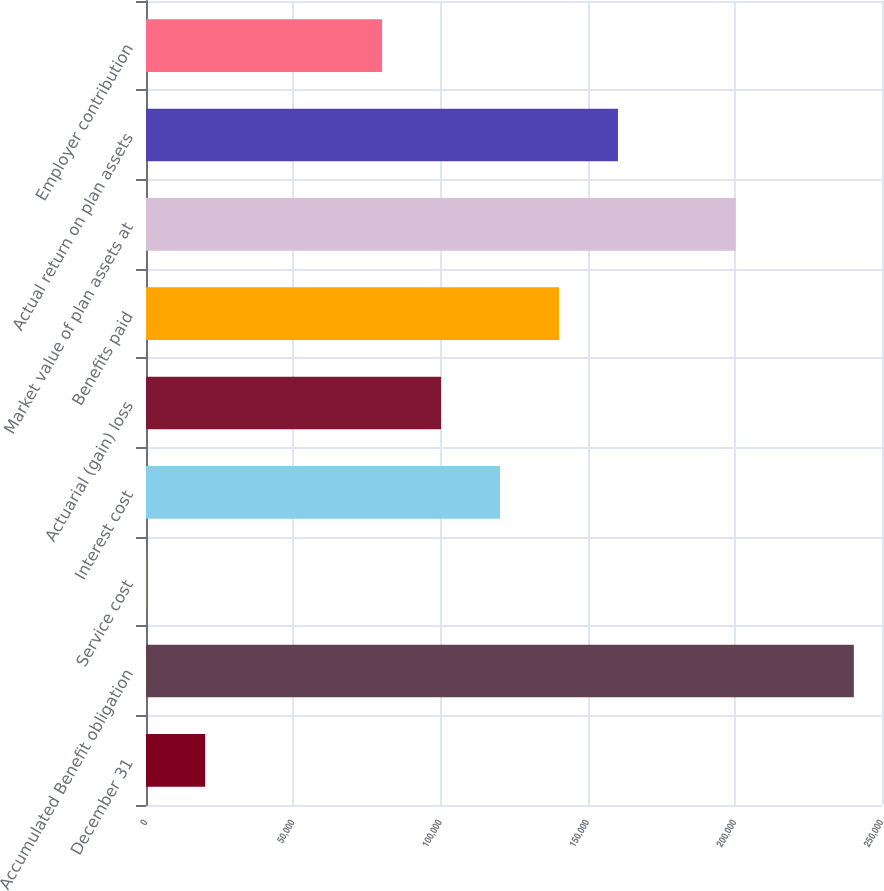Convert chart. <chart><loc_0><loc_0><loc_500><loc_500><bar_chart><fcel>December 31<fcel>Accumulated Benefit obligation<fcel>Service cost<fcel>Interest cost<fcel>Actuarial (gain) loss<fcel>Benefits paid<fcel>Market value of plan assets at<fcel>Actual return on plan assets<fcel>Employer contribution<nl><fcel>20101.4<fcel>240436<fcel>71<fcel>120253<fcel>100223<fcel>140284<fcel>200375<fcel>160314<fcel>80192.6<nl></chart> 